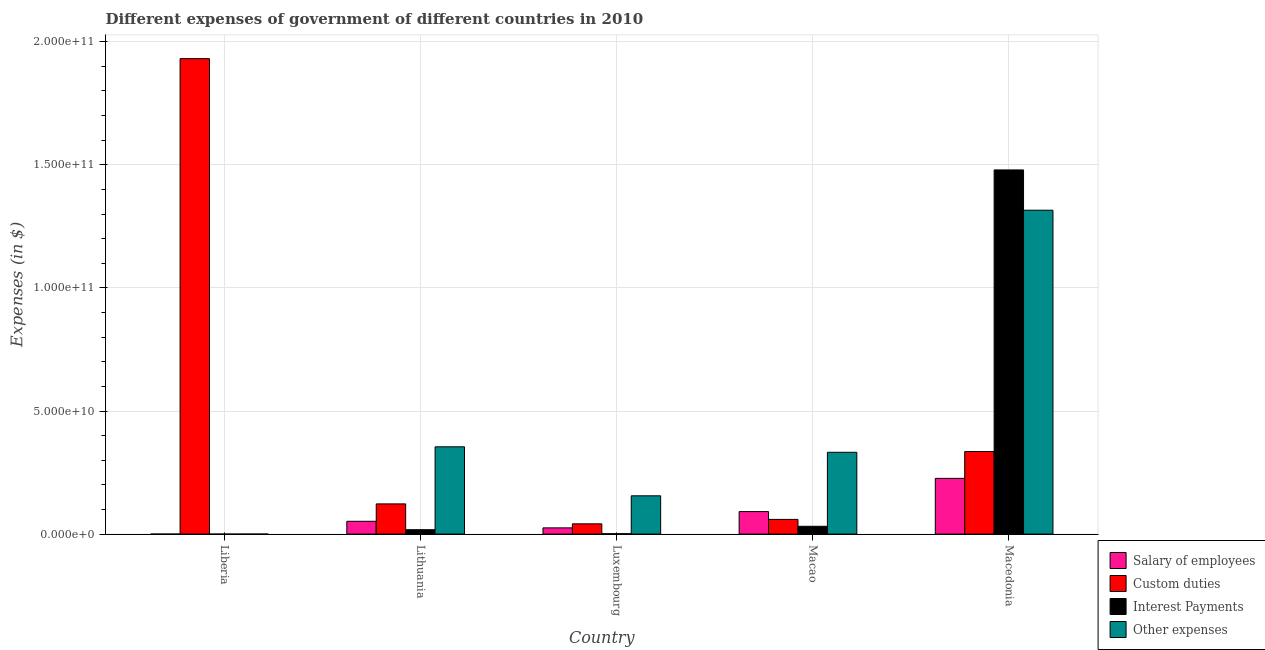How many different coloured bars are there?
Ensure brevity in your answer.  4. How many groups of bars are there?
Give a very brief answer. 5. Are the number of bars per tick equal to the number of legend labels?
Offer a terse response. Yes. Are the number of bars on each tick of the X-axis equal?
Provide a succinct answer. Yes. How many bars are there on the 2nd tick from the right?
Make the answer very short. 4. What is the label of the 2nd group of bars from the left?
Your answer should be very brief. Lithuania. In how many cases, is the number of bars for a given country not equal to the number of legend labels?
Give a very brief answer. 0. What is the amount spent on other expenses in Liberia?
Your response must be concise. 3.80e+06. Across all countries, what is the maximum amount spent on interest payments?
Provide a short and direct response. 1.48e+11. Across all countries, what is the minimum amount spent on salary of employees?
Provide a succinct answer. 1.29e+06. In which country was the amount spent on salary of employees maximum?
Offer a terse response. Macedonia. In which country was the amount spent on interest payments minimum?
Provide a short and direct response. Liberia. What is the total amount spent on custom duties in the graph?
Your response must be concise. 2.49e+11. What is the difference between the amount spent on other expenses in Luxembourg and that in Macedonia?
Give a very brief answer. -1.16e+11. What is the difference between the amount spent on other expenses in Luxembourg and the amount spent on custom duties in Macedonia?
Give a very brief answer. -1.80e+1. What is the average amount spent on salary of employees per country?
Your answer should be very brief. 7.91e+09. What is the difference between the amount spent on other expenses and amount spent on salary of employees in Macao?
Offer a very short reply. 2.41e+1. In how many countries, is the amount spent on other expenses greater than 20000000000 $?
Provide a succinct answer. 3. What is the ratio of the amount spent on custom duties in Luxembourg to that in Macedonia?
Offer a very short reply. 0.12. Is the amount spent on other expenses in Luxembourg less than that in Macao?
Provide a short and direct response. Yes. Is the difference between the amount spent on other expenses in Liberia and Lithuania greater than the difference between the amount spent on salary of employees in Liberia and Lithuania?
Ensure brevity in your answer.  No. What is the difference between the highest and the second highest amount spent on other expenses?
Give a very brief answer. 9.61e+1. What is the difference between the highest and the lowest amount spent on interest payments?
Offer a very short reply. 1.48e+11. In how many countries, is the amount spent on interest payments greater than the average amount spent on interest payments taken over all countries?
Offer a very short reply. 1. Is the sum of the amount spent on salary of employees in Liberia and Macedonia greater than the maximum amount spent on custom duties across all countries?
Offer a terse response. No. Is it the case that in every country, the sum of the amount spent on salary of employees and amount spent on other expenses is greater than the sum of amount spent on custom duties and amount spent on interest payments?
Your answer should be compact. No. What does the 4th bar from the left in Liberia represents?
Make the answer very short. Other expenses. What does the 4th bar from the right in Liberia represents?
Offer a terse response. Salary of employees. How many bars are there?
Make the answer very short. 20. How many countries are there in the graph?
Offer a very short reply. 5. Are the values on the major ticks of Y-axis written in scientific E-notation?
Give a very brief answer. Yes. Does the graph contain grids?
Your answer should be compact. Yes. Where does the legend appear in the graph?
Your answer should be compact. Bottom right. How are the legend labels stacked?
Make the answer very short. Vertical. What is the title of the graph?
Provide a succinct answer. Different expenses of government of different countries in 2010. Does "Macroeconomic management" appear as one of the legend labels in the graph?
Provide a succinct answer. No. What is the label or title of the Y-axis?
Offer a very short reply. Expenses (in $). What is the Expenses (in $) in Salary of employees in Liberia?
Offer a very short reply. 1.29e+06. What is the Expenses (in $) in Custom duties in Liberia?
Provide a succinct answer. 1.93e+11. What is the Expenses (in $) in Interest Payments in Liberia?
Offer a terse response. 1.88e+05. What is the Expenses (in $) in Other expenses in Liberia?
Your answer should be compact. 3.80e+06. What is the Expenses (in $) of Salary of employees in Lithuania?
Give a very brief answer. 5.20e+09. What is the Expenses (in $) of Custom duties in Lithuania?
Your response must be concise. 1.23e+1. What is the Expenses (in $) in Interest Payments in Lithuania?
Make the answer very short. 1.79e+09. What is the Expenses (in $) of Other expenses in Lithuania?
Your answer should be compact. 3.55e+1. What is the Expenses (in $) in Salary of employees in Luxembourg?
Offer a very short reply. 2.53e+09. What is the Expenses (in $) in Custom duties in Luxembourg?
Your response must be concise. 4.17e+09. What is the Expenses (in $) in Interest Payments in Luxembourg?
Give a very brief answer. 1.51e+08. What is the Expenses (in $) in Other expenses in Luxembourg?
Your answer should be compact. 1.56e+1. What is the Expenses (in $) of Salary of employees in Macao?
Provide a succinct answer. 9.15e+09. What is the Expenses (in $) of Custom duties in Macao?
Offer a very short reply. 5.98e+09. What is the Expenses (in $) of Interest Payments in Macao?
Provide a succinct answer. 3.17e+09. What is the Expenses (in $) in Other expenses in Macao?
Offer a terse response. 3.32e+1. What is the Expenses (in $) in Salary of employees in Macedonia?
Your response must be concise. 2.26e+1. What is the Expenses (in $) of Custom duties in Macedonia?
Keep it short and to the point. 3.35e+1. What is the Expenses (in $) in Interest Payments in Macedonia?
Make the answer very short. 1.48e+11. What is the Expenses (in $) in Other expenses in Macedonia?
Give a very brief answer. 1.32e+11. Across all countries, what is the maximum Expenses (in $) in Salary of employees?
Provide a succinct answer. 2.26e+1. Across all countries, what is the maximum Expenses (in $) of Custom duties?
Offer a very short reply. 1.93e+11. Across all countries, what is the maximum Expenses (in $) of Interest Payments?
Your answer should be compact. 1.48e+11. Across all countries, what is the maximum Expenses (in $) of Other expenses?
Your answer should be compact. 1.32e+11. Across all countries, what is the minimum Expenses (in $) in Salary of employees?
Offer a very short reply. 1.29e+06. Across all countries, what is the minimum Expenses (in $) of Custom duties?
Make the answer very short. 4.17e+09. Across all countries, what is the minimum Expenses (in $) of Interest Payments?
Offer a terse response. 1.88e+05. Across all countries, what is the minimum Expenses (in $) of Other expenses?
Your response must be concise. 3.80e+06. What is the total Expenses (in $) of Salary of employees in the graph?
Offer a very short reply. 3.95e+1. What is the total Expenses (in $) of Custom duties in the graph?
Your answer should be compact. 2.49e+11. What is the total Expenses (in $) in Interest Payments in the graph?
Offer a very short reply. 1.53e+11. What is the total Expenses (in $) of Other expenses in the graph?
Offer a terse response. 2.16e+11. What is the difference between the Expenses (in $) of Salary of employees in Liberia and that in Lithuania?
Your answer should be compact. -5.20e+09. What is the difference between the Expenses (in $) of Custom duties in Liberia and that in Lithuania?
Your answer should be compact. 1.81e+11. What is the difference between the Expenses (in $) in Interest Payments in Liberia and that in Lithuania?
Provide a succinct answer. -1.79e+09. What is the difference between the Expenses (in $) of Other expenses in Liberia and that in Lithuania?
Your answer should be compact. -3.55e+1. What is the difference between the Expenses (in $) in Salary of employees in Liberia and that in Luxembourg?
Provide a short and direct response. -2.53e+09. What is the difference between the Expenses (in $) of Custom duties in Liberia and that in Luxembourg?
Your answer should be very brief. 1.89e+11. What is the difference between the Expenses (in $) of Interest Payments in Liberia and that in Luxembourg?
Keep it short and to the point. -1.51e+08. What is the difference between the Expenses (in $) of Other expenses in Liberia and that in Luxembourg?
Give a very brief answer. -1.55e+1. What is the difference between the Expenses (in $) in Salary of employees in Liberia and that in Macao?
Keep it short and to the point. -9.15e+09. What is the difference between the Expenses (in $) in Custom duties in Liberia and that in Macao?
Offer a terse response. 1.87e+11. What is the difference between the Expenses (in $) in Interest Payments in Liberia and that in Macao?
Offer a very short reply. -3.17e+09. What is the difference between the Expenses (in $) in Other expenses in Liberia and that in Macao?
Your response must be concise. -3.32e+1. What is the difference between the Expenses (in $) of Salary of employees in Liberia and that in Macedonia?
Keep it short and to the point. -2.26e+1. What is the difference between the Expenses (in $) in Custom duties in Liberia and that in Macedonia?
Your answer should be compact. 1.60e+11. What is the difference between the Expenses (in $) of Interest Payments in Liberia and that in Macedonia?
Offer a very short reply. -1.48e+11. What is the difference between the Expenses (in $) of Other expenses in Liberia and that in Macedonia?
Offer a terse response. -1.32e+11. What is the difference between the Expenses (in $) of Salary of employees in Lithuania and that in Luxembourg?
Give a very brief answer. 2.67e+09. What is the difference between the Expenses (in $) of Custom duties in Lithuania and that in Luxembourg?
Your answer should be compact. 8.10e+09. What is the difference between the Expenses (in $) in Interest Payments in Lithuania and that in Luxembourg?
Your answer should be compact. 1.64e+09. What is the difference between the Expenses (in $) of Other expenses in Lithuania and that in Luxembourg?
Provide a short and direct response. 1.99e+1. What is the difference between the Expenses (in $) in Salary of employees in Lithuania and that in Macao?
Give a very brief answer. -3.95e+09. What is the difference between the Expenses (in $) of Custom duties in Lithuania and that in Macao?
Provide a succinct answer. 6.29e+09. What is the difference between the Expenses (in $) of Interest Payments in Lithuania and that in Macao?
Ensure brevity in your answer.  -1.38e+09. What is the difference between the Expenses (in $) in Other expenses in Lithuania and that in Macao?
Offer a terse response. 2.22e+09. What is the difference between the Expenses (in $) in Salary of employees in Lithuania and that in Macedonia?
Provide a short and direct response. -1.74e+1. What is the difference between the Expenses (in $) of Custom duties in Lithuania and that in Macedonia?
Your answer should be very brief. -2.13e+1. What is the difference between the Expenses (in $) of Interest Payments in Lithuania and that in Macedonia?
Offer a very short reply. -1.46e+11. What is the difference between the Expenses (in $) in Other expenses in Lithuania and that in Macedonia?
Your answer should be compact. -9.61e+1. What is the difference between the Expenses (in $) of Salary of employees in Luxembourg and that in Macao?
Your answer should be very brief. -6.62e+09. What is the difference between the Expenses (in $) of Custom duties in Luxembourg and that in Macao?
Ensure brevity in your answer.  -1.81e+09. What is the difference between the Expenses (in $) in Interest Payments in Luxembourg and that in Macao?
Give a very brief answer. -3.02e+09. What is the difference between the Expenses (in $) of Other expenses in Luxembourg and that in Macao?
Make the answer very short. -1.77e+1. What is the difference between the Expenses (in $) of Salary of employees in Luxembourg and that in Macedonia?
Your response must be concise. -2.01e+1. What is the difference between the Expenses (in $) in Custom duties in Luxembourg and that in Macedonia?
Give a very brief answer. -2.94e+1. What is the difference between the Expenses (in $) of Interest Payments in Luxembourg and that in Macedonia?
Ensure brevity in your answer.  -1.48e+11. What is the difference between the Expenses (in $) of Other expenses in Luxembourg and that in Macedonia?
Offer a terse response. -1.16e+11. What is the difference between the Expenses (in $) in Salary of employees in Macao and that in Macedonia?
Provide a succinct answer. -1.35e+1. What is the difference between the Expenses (in $) of Custom duties in Macao and that in Macedonia?
Ensure brevity in your answer.  -2.76e+1. What is the difference between the Expenses (in $) of Interest Payments in Macao and that in Macedonia?
Your response must be concise. -1.45e+11. What is the difference between the Expenses (in $) of Other expenses in Macao and that in Macedonia?
Give a very brief answer. -9.83e+1. What is the difference between the Expenses (in $) of Salary of employees in Liberia and the Expenses (in $) of Custom duties in Lithuania?
Provide a succinct answer. -1.23e+1. What is the difference between the Expenses (in $) in Salary of employees in Liberia and the Expenses (in $) in Interest Payments in Lithuania?
Your response must be concise. -1.79e+09. What is the difference between the Expenses (in $) in Salary of employees in Liberia and the Expenses (in $) in Other expenses in Lithuania?
Give a very brief answer. -3.55e+1. What is the difference between the Expenses (in $) in Custom duties in Liberia and the Expenses (in $) in Interest Payments in Lithuania?
Provide a short and direct response. 1.91e+11. What is the difference between the Expenses (in $) of Custom duties in Liberia and the Expenses (in $) of Other expenses in Lithuania?
Provide a short and direct response. 1.58e+11. What is the difference between the Expenses (in $) of Interest Payments in Liberia and the Expenses (in $) of Other expenses in Lithuania?
Your response must be concise. -3.55e+1. What is the difference between the Expenses (in $) in Salary of employees in Liberia and the Expenses (in $) in Custom duties in Luxembourg?
Provide a short and direct response. -4.17e+09. What is the difference between the Expenses (in $) of Salary of employees in Liberia and the Expenses (in $) of Interest Payments in Luxembourg?
Provide a short and direct response. -1.50e+08. What is the difference between the Expenses (in $) in Salary of employees in Liberia and the Expenses (in $) in Other expenses in Luxembourg?
Provide a succinct answer. -1.56e+1. What is the difference between the Expenses (in $) of Custom duties in Liberia and the Expenses (in $) of Interest Payments in Luxembourg?
Your answer should be very brief. 1.93e+11. What is the difference between the Expenses (in $) in Custom duties in Liberia and the Expenses (in $) in Other expenses in Luxembourg?
Offer a terse response. 1.78e+11. What is the difference between the Expenses (in $) in Interest Payments in Liberia and the Expenses (in $) in Other expenses in Luxembourg?
Ensure brevity in your answer.  -1.56e+1. What is the difference between the Expenses (in $) in Salary of employees in Liberia and the Expenses (in $) in Custom duties in Macao?
Your answer should be compact. -5.97e+09. What is the difference between the Expenses (in $) in Salary of employees in Liberia and the Expenses (in $) in Interest Payments in Macao?
Ensure brevity in your answer.  -3.17e+09. What is the difference between the Expenses (in $) in Salary of employees in Liberia and the Expenses (in $) in Other expenses in Macao?
Give a very brief answer. -3.32e+1. What is the difference between the Expenses (in $) in Custom duties in Liberia and the Expenses (in $) in Interest Payments in Macao?
Offer a terse response. 1.90e+11. What is the difference between the Expenses (in $) of Custom duties in Liberia and the Expenses (in $) of Other expenses in Macao?
Offer a very short reply. 1.60e+11. What is the difference between the Expenses (in $) of Interest Payments in Liberia and the Expenses (in $) of Other expenses in Macao?
Offer a terse response. -3.32e+1. What is the difference between the Expenses (in $) in Salary of employees in Liberia and the Expenses (in $) in Custom duties in Macedonia?
Make the answer very short. -3.35e+1. What is the difference between the Expenses (in $) of Salary of employees in Liberia and the Expenses (in $) of Interest Payments in Macedonia?
Keep it short and to the point. -1.48e+11. What is the difference between the Expenses (in $) of Salary of employees in Liberia and the Expenses (in $) of Other expenses in Macedonia?
Provide a succinct answer. -1.32e+11. What is the difference between the Expenses (in $) of Custom duties in Liberia and the Expenses (in $) of Interest Payments in Macedonia?
Offer a very short reply. 4.52e+1. What is the difference between the Expenses (in $) in Custom duties in Liberia and the Expenses (in $) in Other expenses in Macedonia?
Provide a short and direct response. 6.16e+1. What is the difference between the Expenses (in $) in Interest Payments in Liberia and the Expenses (in $) in Other expenses in Macedonia?
Give a very brief answer. -1.32e+11. What is the difference between the Expenses (in $) in Salary of employees in Lithuania and the Expenses (in $) in Custom duties in Luxembourg?
Provide a succinct answer. 1.04e+09. What is the difference between the Expenses (in $) in Salary of employees in Lithuania and the Expenses (in $) in Interest Payments in Luxembourg?
Give a very brief answer. 5.05e+09. What is the difference between the Expenses (in $) of Salary of employees in Lithuania and the Expenses (in $) of Other expenses in Luxembourg?
Ensure brevity in your answer.  -1.03e+1. What is the difference between the Expenses (in $) of Custom duties in Lithuania and the Expenses (in $) of Interest Payments in Luxembourg?
Ensure brevity in your answer.  1.21e+1. What is the difference between the Expenses (in $) of Custom duties in Lithuania and the Expenses (in $) of Other expenses in Luxembourg?
Ensure brevity in your answer.  -3.28e+09. What is the difference between the Expenses (in $) of Interest Payments in Lithuania and the Expenses (in $) of Other expenses in Luxembourg?
Keep it short and to the point. -1.38e+1. What is the difference between the Expenses (in $) in Salary of employees in Lithuania and the Expenses (in $) in Custom duties in Macao?
Provide a succinct answer. -7.71e+08. What is the difference between the Expenses (in $) in Salary of employees in Lithuania and the Expenses (in $) in Interest Payments in Macao?
Ensure brevity in your answer.  2.03e+09. What is the difference between the Expenses (in $) in Salary of employees in Lithuania and the Expenses (in $) in Other expenses in Macao?
Keep it short and to the point. -2.80e+1. What is the difference between the Expenses (in $) of Custom duties in Lithuania and the Expenses (in $) of Interest Payments in Macao?
Provide a succinct answer. 9.10e+09. What is the difference between the Expenses (in $) in Custom duties in Lithuania and the Expenses (in $) in Other expenses in Macao?
Make the answer very short. -2.10e+1. What is the difference between the Expenses (in $) in Interest Payments in Lithuania and the Expenses (in $) in Other expenses in Macao?
Provide a succinct answer. -3.14e+1. What is the difference between the Expenses (in $) in Salary of employees in Lithuania and the Expenses (in $) in Custom duties in Macedonia?
Ensure brevity in your answer.  -2.83e+1. What is the difference between the Expenses (in $) of Salary of employees in Lithuania and the Expenses (in $) of Interest Payments in Macedonia?
Your response must be concise. -1.43e+11. What is the difference between the Expenses (in $) in Salary of employees in Lithuania and the Expenses (in $) in Other expenses in Macedonia?
Your answer should be very brief. -1.26e+11. What is the difference between the Expenses (in $) in Custom duties in Lithuania and the Expenses (in $) in Interest Payments in Macedonia?
Your response must be concise. -1.36e+11. What is the difference between the Expenses (in $) of Custom duties in Lithuania and the Expenses (in $) of Other expenses in Macedonia?
Your answer should be very brief. -1.19e+11. What is the difference between the Expenses (in $) in Interest Payments in Lithuania and the Expenses (in $) in Other expenses in Macedonia?
Give a very brief answer. -1.30e+11. What is the difference between the Expenses (in $) of Salary of employees in Luxembourg and the Expenses (in $) of Custom duties in Macao?
Offer a terse response. -3.44e+09. What is the difference between the Expenses (in $) of Salary of employees in Luxembourg and the Expenses (in $) of Interest Payments in Macao?
Ensure brevity in your answer.  -6.43e+08. What is the difference between the Expenses (in $) of Salary of employees in Luxembourg and the Expenses (in $) of Other expenses in Macao?
Keep it short and to the point. -3.07e+1. What is the difference between the Expenses (in $) of Custom duties in Luxembourg and the Expenses (in $) of Interest Payments in Macao?
Provide a succinct answer. 9.96e+08. What is the difference between the Expenses (in $) in Custom duties in Luxembourg and the Expenses (in $) in Other expenses in Macao?
Keep it short and to the point. -2.91e+1. What is the difference between the Expenses (in $) of Interest Payments in Luxembourg and the Expenses (in $) of Other expenses in Macao?
Give a very brief answer. -3.31e+1. What is the difference between the Expenses (in $) of Salary of employees in Luxembourg and the Expenses (in $) of Custom duties in Macedonia?
Offer a terse response. -3.10e+1. What is the difference between the Expenses (in $) of Salary of employees in Luxembourg and the Expenses (in $) of Interest Payments in Macedonia?
Your answer should be compact. -1.45e+11. What is the difference between the Expenses (in $) in Salary of employees in Luxembourg and the Expenses (in $) in Other expenses in Macedonia?
Provide a succinct answer. -1.29e+11. What is the difference between the Expenses (in $) in Custom duties in Luxembourg and the Expenses (in $) in Interest Payments in Macedonia?
Provide a succinct answer. -1.44e+11. What is the difference between the Expenses (in $) in Custom duties in Luxembourg and the Expenses (in $) in Other expenses in Macedonia?
Your response must be concise. -1.27e+11. What is the difference between the Expenses (in $) in Interest Payments in Luxembourg and the Expenses (in $) in Other expenses in Macedonia?
Your response must be concise. -1.31e+11. What is the difference between the Expenses (in $) of Salary of employees in Macao and the Expenses (in $) of Custom duties in Macedonia?
Provide a succinct answer. -2.44e+1. What is the difference between the Expenses (in $) of Salary of employees in Macao and the Expenses (in $) of Interest Payments in Macedonia?
Your answer should be compact. -1.39e+11. What is the difference between the Expenses (in $) in Salary of employees in Macao and the Expenses (in $) in Other expenses in Macedonia?
Your answer should be compact. -1.22e+11. What is the difference between the Expenses (in $) in Custom duties in Macao and the Expenses (in $) in Interest Payments in Macedonia?
Your answer should be very brief. -1.42e+11. What is the difference between the Expenses (in $) in Custom duties in Macao and the Expenses (in $) in Other expenses in Macedonia?
Provide a succinct answer. -1.26e+11. What is the difference between the Expenses (in $) of Interest Payments in Macao and the Expenses (in $) of Other expenses in Macedonia?
Your answer should be very brief. -1.28e+11. What is the average Expenses (in $) of Salary of employees per country?
Your answer should be very brief. 7.91e+09. What is the average Expenses (in $) of Custom duties per country?
Keep it short and to the point. 4.98e+1. What is the average Expenses (in $) of Interest Payments per country?
Give a very brief answer. 3.06e+1. What is the average Expenses (in $) of Other expenses per country?
Your response must be concise. 4.32e+1. What is the difference between the Expenses (in $) of Salary of employees and Expenses (in $) of Custom duties in Liberia?
Keep it short and to the point. -1.93e+11. What is the difference between the Expenses (in $) of Salary of employees and Expenses (in $) of Interest Payments in Liberia?
Give a very brief answer. 1.10e+06. What is the difference between the Expenses (in $) in Salary of employees and Expenses (in $) in Other expenses in Liberia?
Offer a terse response. -2.51e+06. What is the difference between the Expenses (in $) of Custom duties and Expenses (in $) of Interest Payments in Liberia?
Provide a succinct answer. 1.93e+11. What is the difference between the Expenses (in $) of Custom duties and Expenses (in $) of Other expenses in Liberia?
Your answer should be compact. 1.93e+11. What is the difference between the Expenses (in $) of Interest Payments and Expenses (in $) of Other expenses in Liberia?
Your answer should be very brief. -3.61e+06. What is the difference between the Expenses (in $) of Salary of employees and Expenses (in $) of Custom duties in Lithuania?
Give a very brief answer. -7.06e+09. What is the difference between the Expenses (in $) of Salary of employees and Expenses (in $) of Interest Payments in Lithuania?
Offer a very short reply. 3.42e+09. What is the difference between the Expenses (in $) of Salary of employees and Expenses (in $) of Other expenses in Lithuania?
Your response must be concise. -3.03e+1. What is the difference between the Expenses (in $) in Custom duties and Expenses (in $) in Interest Payments in Lithuania?
Provide a succinct answer. 1.05e+1. What is the difference between the Expenses (in $) of Custom duties and Expenses (in $) of Other expenses in Lithuania?
Offer a very short reply. -2.32e+1. What is the difference between the Expenses (in $) in Interest Payments and Expenses (in $) in Other expenses in Lithuania?
Provide a short and direct response. -3.37e+1. What is the difference between the Expenses (in $) in Salary of employees and Expenses (in $) in Custom duties in Luxembourg?
Provide a succinct answer. -1.64e+09. What is the difference between the Expenses (in $) in Salary of employees and Expenses (in $) in Interest Payments in Luxembourg?
Offer a very short reply. 2.38e+09. What is the difference between the Expenses (in $) of Salary of employees and Expenses (in $) of Other expenses in Luxembourg?
Provide a succinct answer. -1.30e+1. What is the difference between the Expenses (in $) in Custom duties and Expenses (in $) in Interest Payments in Luxembourg?
Make the answer very short. 4.02e+09. What is the difference between the Expenses (in $) of Custom duties and Expenses (in $) of Other expenses in Luxembourg?
Your answer should be very brief. -1.14e+1. What is the difference between the Expenses (in $) in Interest Payments and Expenses (in $) in Other expenses in Luxembourg?
Your response must be concise. -1.54e+1. What is the difference between the Expenses (in $) of Salary of employees and Expenses (in $) of Custom duties in Macao?
Offer a terse response. 3.17e+09. What is the difference between the Expenses (in $) of Salary of employees and Expenses (in $) of Interest Payments in Macao?
Provide a short and direct response. 5.98e+09. What is the difference between the Expenses (in $) of Salary of employees and Expenses (in $) of Other expenses in Macao?
Give a very brief answer. -2.41e+1. What is the difference between the Expenses (in $) in Custom duties and Expenses (in $) in Interest Payments in Macao?
Provide a short and direct response. 2.80e+09. What is the difference between the Expenses (in $) in Custom duties and Expenses (in $) in Other expenses in Macao?
Ensure brevity in your answer.  -2.73e+1. What is the difference between the Expenses (in $) of Interest Payments and Expenses (in $) of Other expenses in Macao?
Ensure brevity in your answer.  -3.01e+1. What is the difference between the Expenses (in $) in Salary of employees and Expenses (in $) in Custom duties in Macedonia?
Your answer should be compact. -1.09e+1. What is the difference between the Expenses (in $) in Salary of employees and Expenses (in $) in Interest Payments in Macedonia?
Your response must be concise. -1.25e+11. What is the difference between the Expenses (in $) in Salary of employees and Expenses (in $) in Other expenses in Macedonia?
Ensure brevity in your answer.  -1.09e+11. What is the difference between the Expenses (in $) in Custom duties and Expenses (in $) in Interest Payments in Macedonia?
Your response must be concise. -1.14e+11. What is the difference between the Expenses (in $) of Custom duties and Expenses (in $) of Other expenses in Macedonia?
Keep it short and to the point. -9.80e+1. What is the difference between the Expenses (in $) of Interest Payments and Expenses (in $) of Other expenses in Macedonia?
Keep it short and to the point. 1.64e+1. What is the ratio of the Expenses (in $) of Salary of employees in Liberia to that in Lithuania?
Make the answer very short. 0. What is the ratio of the Expenses (in $) in Custom duties in Liberia to that in Lithuania?
Provide a succinct answer. 15.74. What is the ratio of the Expenses (in $) in Interest Payments in Liberia to that in Lithuania?
Keep it short and to the point. 0. What is the ratio of the Expenses (in $) of Other expenses in Liberia to that in Lithuania?
Offer a terse response. 0. What is the ratio of the Expenses (in $) in Custom duties in Liberia to that in Luxembourg?
Offer a very short reply. 46.32. What is the ratio of the Expenses (in $) of Interest Payments in Liberia to that in Luxembourg?
Ensure brevity in your answer.  0. What is the ratio of the Expenses (in $) of Other expenses in Liberia to that in Luxembourg?
Offer a very short reply. 0. What is the ratio of the Expenses (in $) in Salary of employees in Liberia to that in Macao?
Give a very brief answer. 0. What is the ratio of the Expenses (in $) of Custom duties in Liberia to that in Macao?
Ensure brevity in your answer.  32.32. What is the ratio of the Expenses (in $) in Interest Payments in Liberia to that in Macao?
Give a very brief answer. 0. What is the ratio of the Expenses (in $) of Other expenses in Liberia to that in Macao?
Make the answer very short. 0. What is the ratio of the Expenses (in $) of Custom duties in Liberia to that in Macedonia?
Keep it short and to the point. 5.76. What is the ratio of the Expenses (in $) of Salary of employees in Lithuania to that in Luxembourg?
Your response must be concise. 2.06. What is the ratio of the Expenses (in $) in Custom duties in Lithuania to that in Luxembourg?
Your answer should be very brief. 2.94. What is the ratio of the Expenses (in $) of Interest Payments in Lithuania to that in Luxembourg?
Your answer should be compact. 11.86. What is the ratio of the Expenses (in $) in Other expenses in Lithuania to that in Luxembourg?
Offer a terse response. 2.28. What is the ratio of the Expenses (in $) of Salary of employees in Lithuania to that in Macao?
Your answer should be compact. 0.57. What is the ratio of the Expenses (in $) of Custom duties in Lithuania to that in Macao?
Make the answer very short. 2.05. What is the ratio of the Expenses (in $) in Interest Payments in Lithuania to that in Macao?
Provide a short and direct response. 0.56. What is the ratio of the Expenses (in $) of Other expenses in Lithuania to that in Macao?
Offer a very short reply. 1.07. What is the ratio of the Expenses (in $) in Salary of employees in Lithuania to that in Macedonia?
Ensure brevity in your answer.  0.23. What is the ratio of the Expenses (in $) in Custom duties in Lithuania to that in Macedonia?
Provide a short and direct response. 0.37. What is the ratio of the Expenses (in $) of Interest Payments in Lithuania to that in Macedonia?
Make the answer very short. 0.01. What is the ratio of the Expenses (in $) of Other expenses in Lithuania to that in Macedonia?
Make the answer very short. 0.27. What is the ratio of the Expenses (in $) in Salary of employees in Luxembourg to that in Macao?
Provide a short and direct response. 0.28. What is the ratio of the Expenses (in $) of Custom duties in Luxembourg to that in Macao?
Make the answer very short. 0.7. What is the ratio of the Expenses (in $) in Interest Payments in Luxembourg to that in Macao?
Ensure brevity in your answer.  0.05. What is the ratio of the Expenses (in $) of Other expenses in Luxembourg to that in Macao?
Your answer should be very brief. 0.47. What is the ratio of the Expenses (in $) in Salary of employees in Luxembourg to that in Macedonia?
Offer a terse response. 0.11. What is the ratio of the Expenses (in $) in Custom duties in Luxembourg to that in Macedonia?
Provide a succinct answer. 0.12. What is the ratio of the Expenses (in $) in Other expenses in Luxembourg to that in Macedonia?
Your response must be concise. 0.12. What is the ratio of the Expenses (in $) of Salary of employees in Macao to that in Macedonia?
Give a very brief answer. 0.4. What is the ratio of the Expenses (in $) of Custom duties in Macao to that in Macedonia?
Keep it short and to the point. 0.18. What is the ratio of the Expenses (in $) of Interest Payments in Macao to that in Macedonia?
Your response must be concise. 0.02. What is the ratio of the Expenses (in $) of Other expenses in Macao to that in Macedonia?
Provide a succinct answer. 0.25. What is the difference between the highest and the second highest Expenses (in $) in Salary of employees?
Your answer should be compact. 1.35e+1. What is the difference between the highest and the second highest Expenses (in $) of Custom duties?
Provide a succinct answer. 1.60e+11. What is the difference between the highest and the second highest Expenses (in $) of Interest Payments?
Provide a short and direct response. 1.45e+11. What is the difference between the highest and the second highest Expenses (in $) of Other expenses?
Keep it short and to the point. 9.61e+1. What is the difference between the highest and the lowest Expenses (in $) in Salary of employees?
Keep it short and to the point. 2.26e+1. What is the difference between the highest and the lowest Expenses (in $) in Custom duties?
Offer a terse response. 1.89e+11. What is the difference between the highest and the lowest Expenses (in $) of Interest Payments?
Provide a short and direct response. 1.48e+11. What is the difference between the highest and the lowest Expenses (in $) of Other expenses?
Offer a terse response. 1.32e+11. 